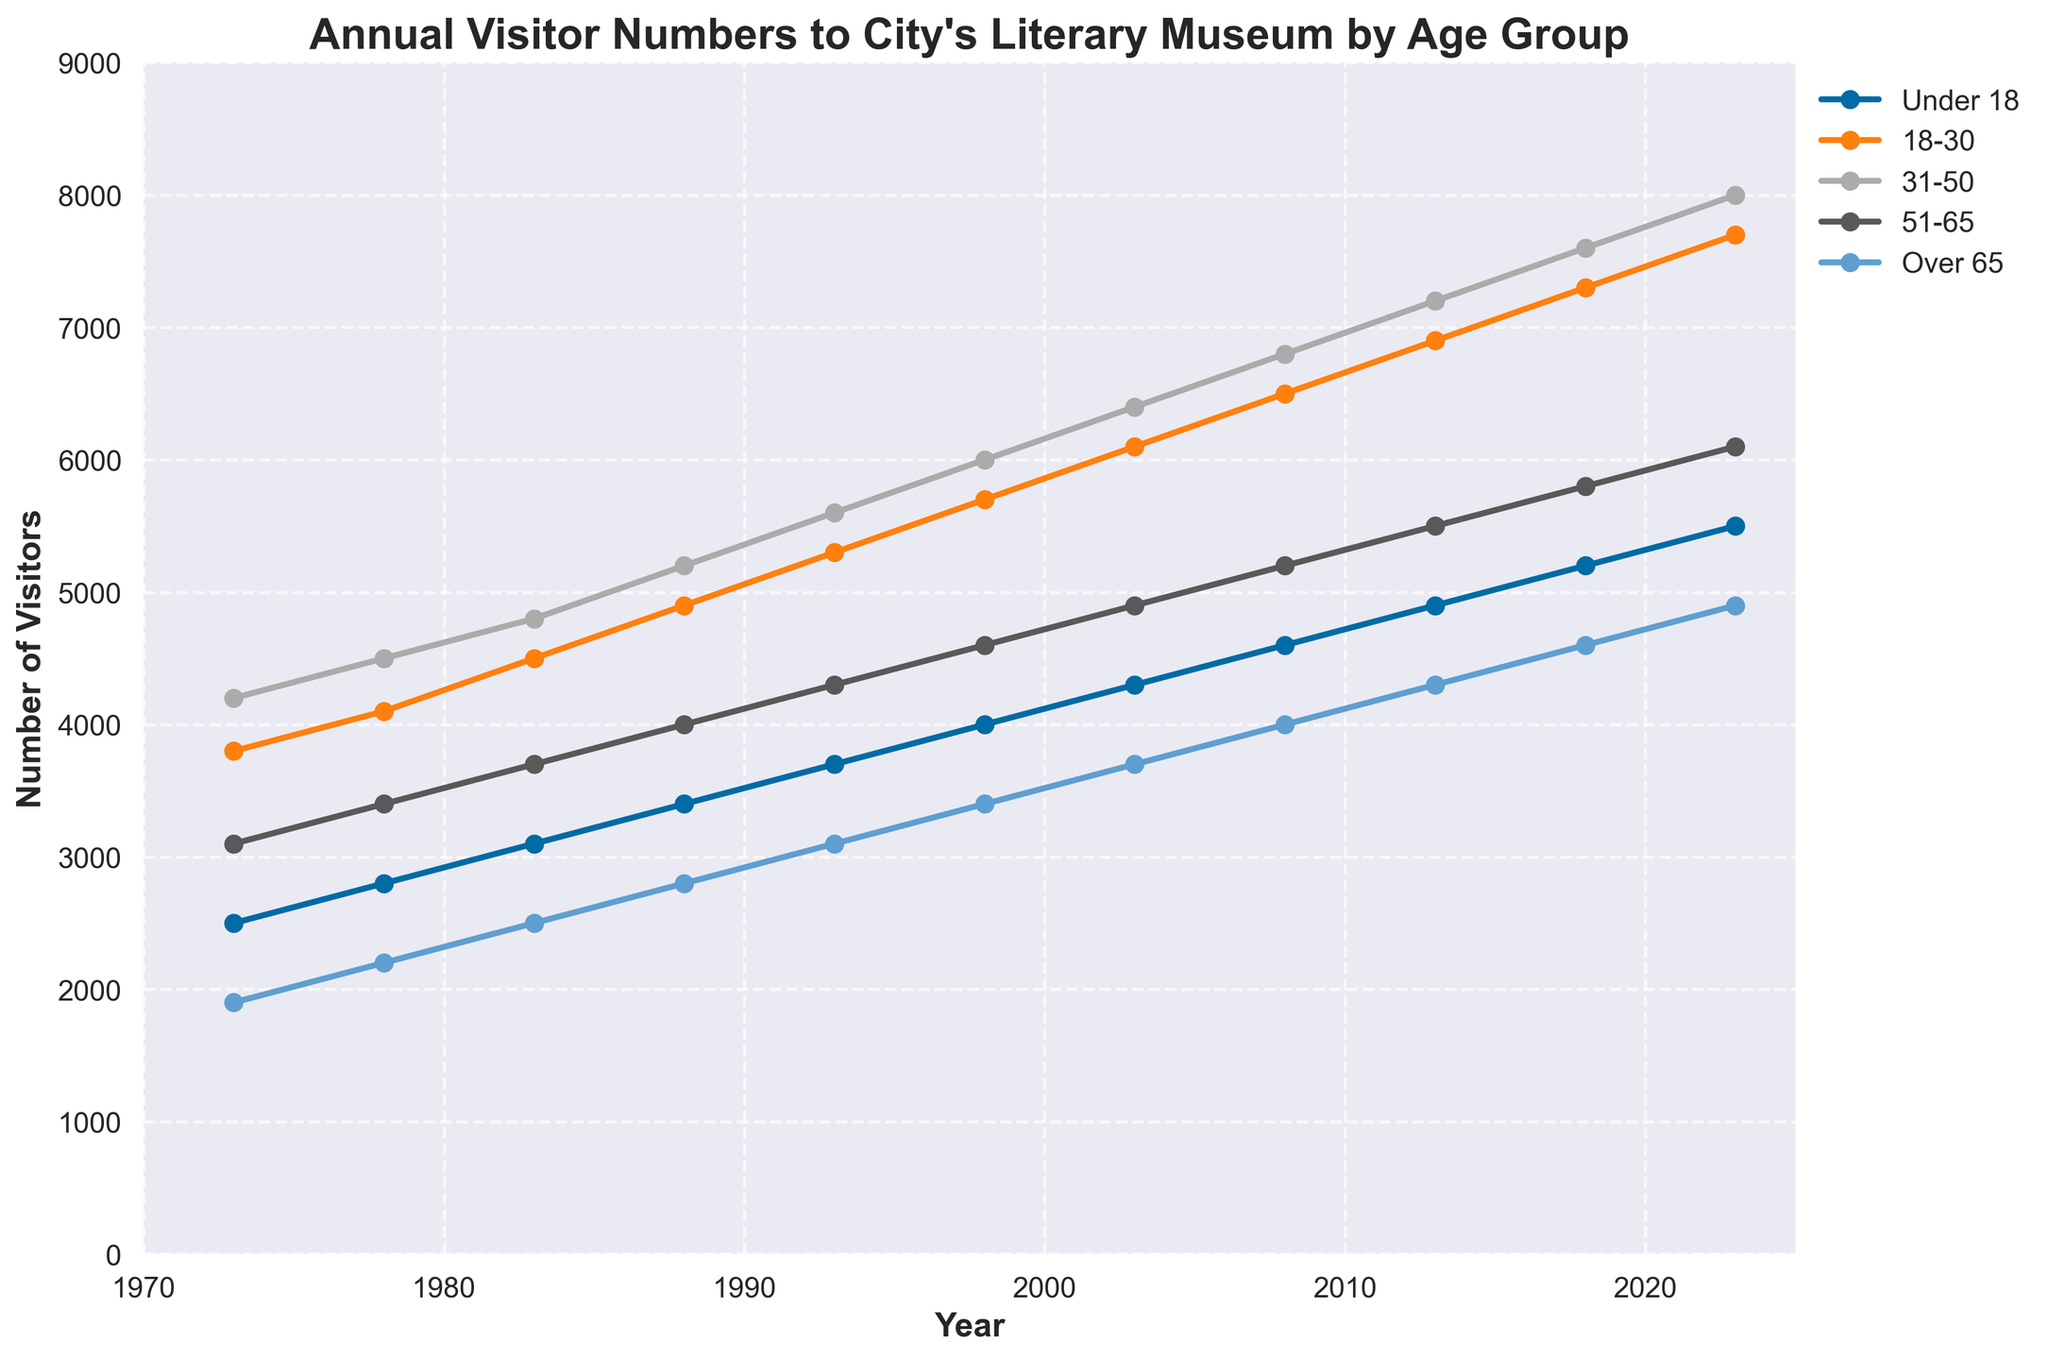What is the overall trend in annual visitors for the 'Under 18' age group over the 50-year period? The 'Under 18' age group shows a steady increase in the number of annual visitors over the 50-year period, starting from 2500 in 1973 to 5500 in 2023. This indicates a growing interest from younger visitors.
Answer: Steady increase Which age group had the highest number of visitors in 2023? In 2023, the '31-50' age group had the highest number of visitors at 8000. This is determined by looking at the peak value of the lines on the rightmost end of the chart.
Answer: 31-50 In which year did the '18-30' age group surpass the 5000 visitors mark, and what was their exact number at that point? The '18-30' age group surpassed 5000 visitors in the year 1993, with a total of 5300 visitors. This is determined by following the '18-30' line and marking the year it crosses the 5000 mark.
Answer: 1993, 5300 How does the number of visitors aged 'Over 65' in 2018 compare to the number of visitors aged 'Under 18' in the same year? In 2018, the 'Over 65' age group had 4600 visitors, whereas the 'Under 18' age group had 5200 visitors. Therefore, the 'Under 18' visitors were greater by 600.
Answer: 600 more 'Under 18' Calculate the average annual visitors for the '51-65' age group over the entire period. To find the average, sum the visitors for '51-65' over all the years (3100+3400+3700+4000+4300+4600+4900+5200+5500+5800+6100 = 50600) and divide by the number of years (11). 50600/11 ≈ 4600
Answer: 4600 Which age group has shown the most significant increase in annual visitors from 1973 to 2023, and by how much did it increase? The '31-50' age group showed the most significant increase in annual visitors from 4200 in 1973 to 8000 in 2023. The increase is calculated as 8000 - 4200 = 3800.
Answer: 31-50, 3800 During which decade did the '51-65' age group see the highest growth in visitor numbers, and what was the growth amount? The '51-65' age group saw the highest growth during the 1980s decade (1983 to 1993), where the number increased from 3700 to 4300. The growth amount is 4300 - 3700 = 600.
Answer: 1980s, 600 What is the rate of change in the number of visitors for the '18-30' age group from 2003 to 2013? The rate of change is calculated by the difference in the number of visitors between 2013 (6900) and 2003 (6100), divided by the number of years (10). (6900 - 6100) / 10 = 80 visitors per year.
Answer: 80 visitors per year Compare the visitor numbers of the 'Under 18' and 'Over 65' age groups in 1973. Which group had more visitors and by how much? In 1973, the 'Under 18' age group had 2500 visitors, and the 'Over 65' age group had 1900 visitors. The 'Under 18' had more visitors by 2500 - 1900 = 600.
Answer: Under 18, 600 Which three years show the largest yearly increase in visitor numbers for the '31-50' age group? Provide the corresponding increase values. The years with the largest yearly increase for the '31-50' age group are 1988 (3200 -> 3400 = 200), 1998 (3700 -> 4600 = 900), and 2003 (4600 -> 4900 = 300). Summarizing the values, this means the most significant increases occurred in 1998 by 900, 2003 by 300, and 1988 by 200.
Answer: 1998, 900; 2003, 300; 1988, 200 